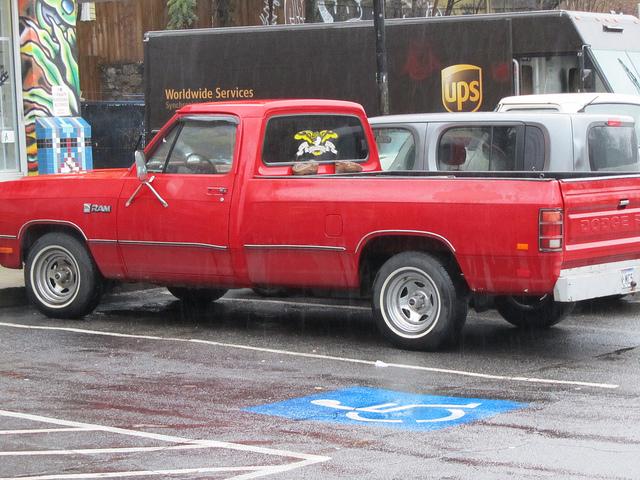What does his window decal indicate?
Be succinct. Military. Is the truck clean?
Concise answer only. No. Is the truck moving?
Be succinct. No. Is this a Japanese vehicle?
Quick response, please. No. Is the red truck contemporary or classic?
Quick response, please. Classic. 